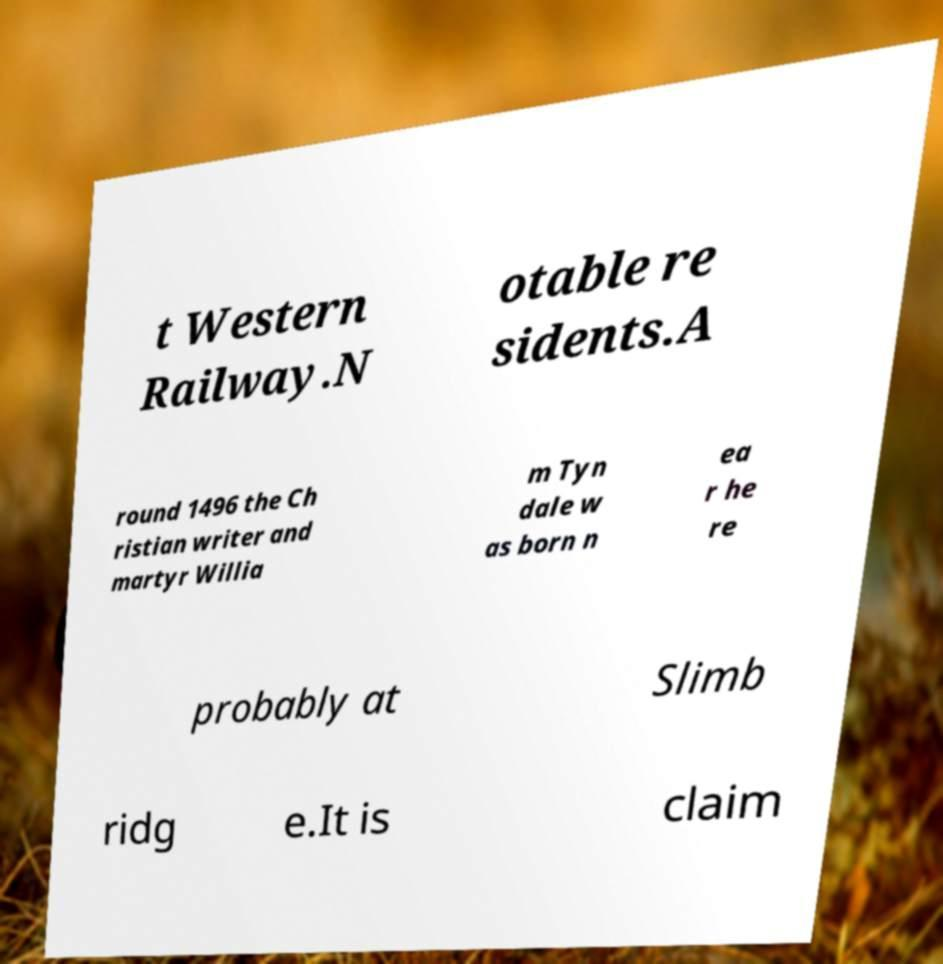I need the written content from this picture converted into text. Can you do that? t Western Railway.N otable re sidents.A round 1496 the Ch ristian writer and martyr Willia m Tyn dale w as born n ea r he re probably at Slimb ridg e.It is claim 